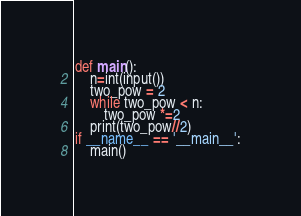Convert code to text. <code><loc_0><loc_0><loc_500><loc_500><_Python_>def main():
    n=int(input())
    two_pow = 2
    while two_pow < n:
        two_pow *=2
    print(two_pow//2)
if __name__ == '__main__':
    main()
</code> 